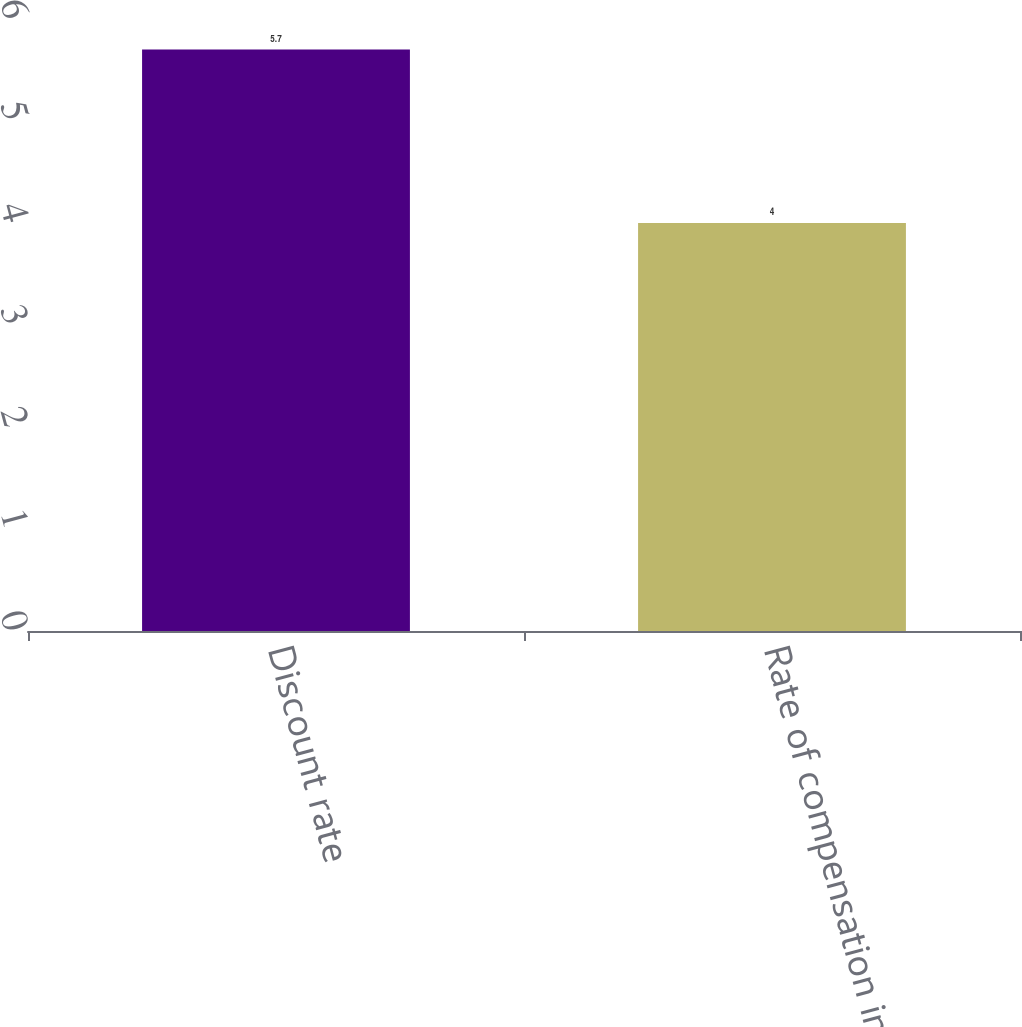<chart> <loc_0><loc_0><loc_500><loc_500><bar_chart><fcel>Discount rate<fcel>Rate of compensation increase<nl><fcel>5.7<fcel>4<nl></chart> 